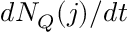<formula> <loc_0><loc_0><loc_500><loc_500>d N _ { Q } ( j ) / d t</formula> 